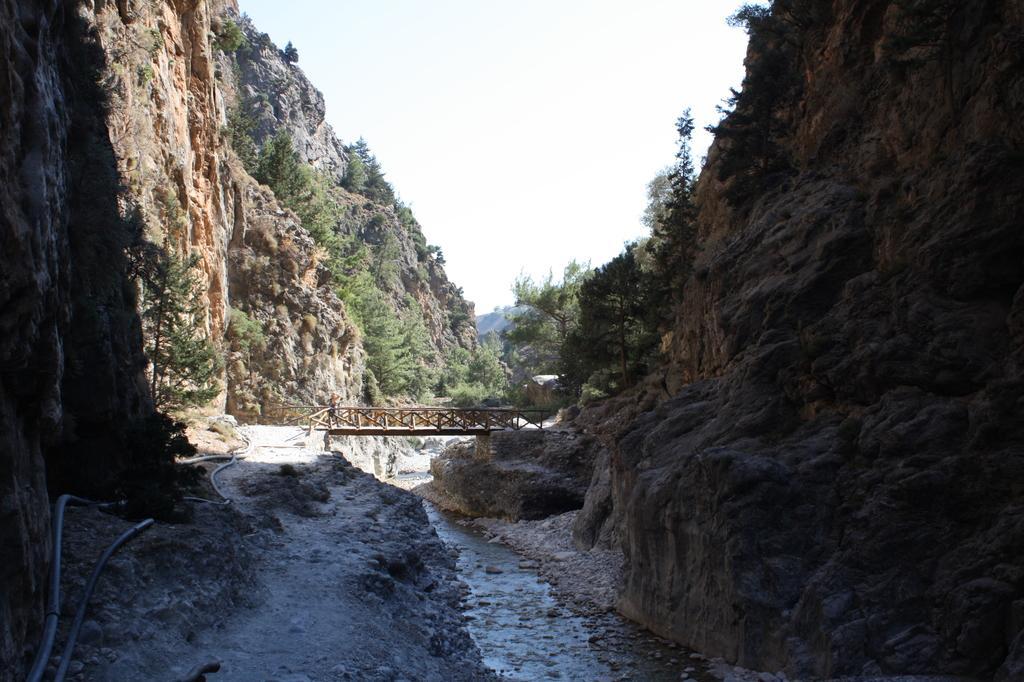What is the main feature of the image? The main feature of the image is water. What can be seen on both sides of the water? There are mountains on both sides of the water. What is visible in the background of the image? In the background, there is a bridge, many trees, and the sky. How many passengers are on the island in the image? There is no island present in the image; it features water with mountains on both sides and a background with a bridge, trees, and the sky. 